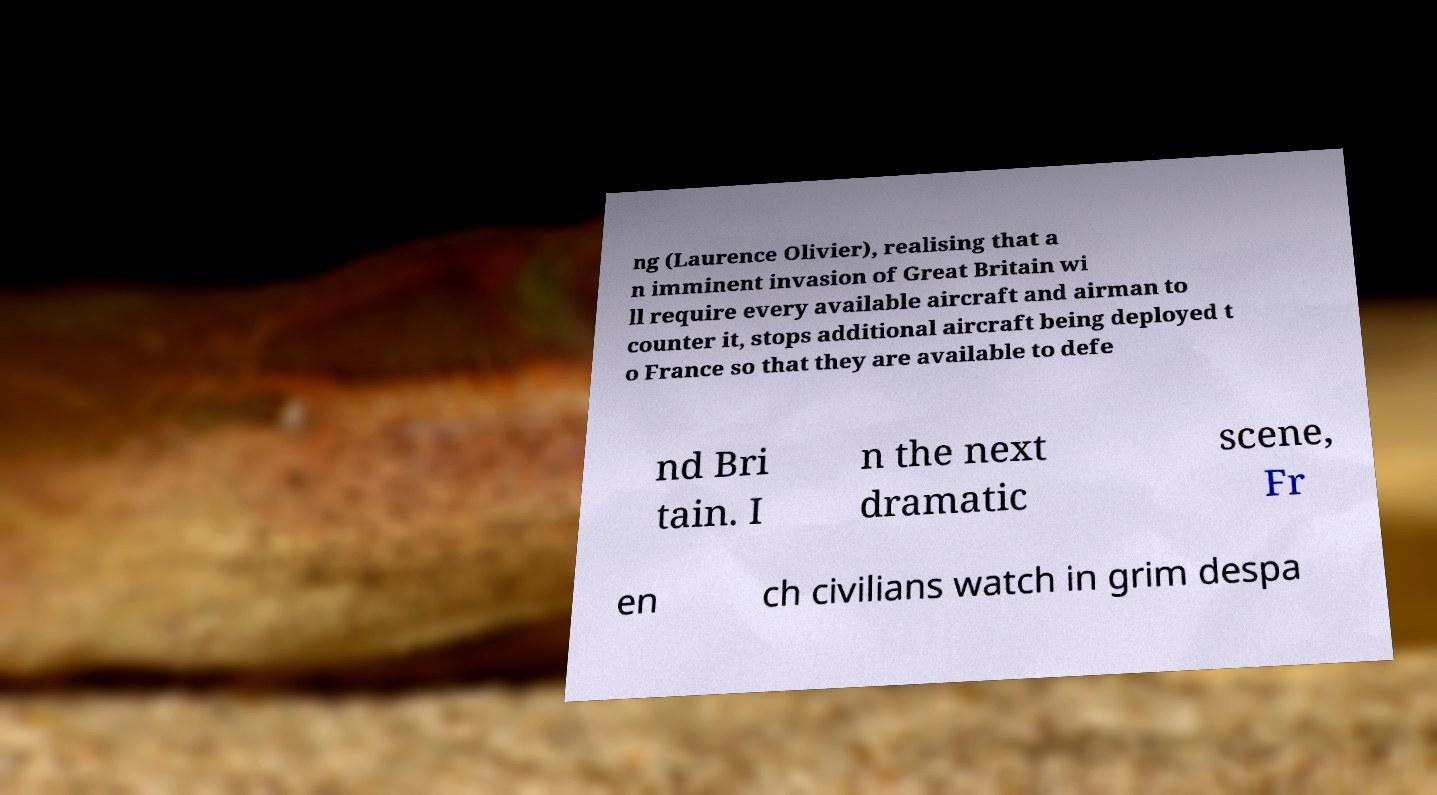Please identify and transcribe the text found in this image. ng (Laurence Olivier), realising that a n imminent invasion of Great Britain wi ll require every available aircraft and airman to counter it, stops additional aircraft being deployed t o France so that they are available to defe nd Bri tain. I n the next dramatic scene, Fr en ch civilians watch in grim despa 